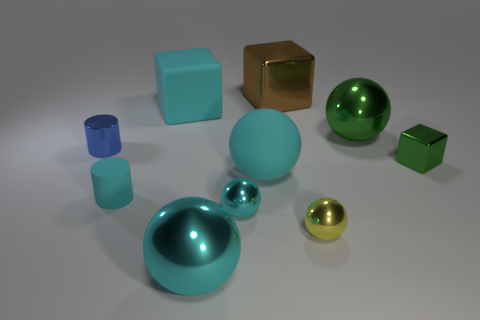Subtract all metallic blocks. How many blocks are left? 1 Subtract all cyan balls. How many balls are left? 2 Subtract 1 balls. How many balls are left? 4 Subtract all cubes. How many objects are left? 7 Subtract all green balls. Subtract all cyan cylinders. How many balls are left? 4 Subtract all green cylinders. How many cyan spheres are left? 3 Subtract all large cyan things. Subtract all big shiny balls. How many objects are left? 5 Add 5 brown metallic blocks. How many brown metallic blocks are left? 6 Add 6 green balls. How many green balls exist? 7 Subtract 1 cyan cylinders. How many objects are left? 9 